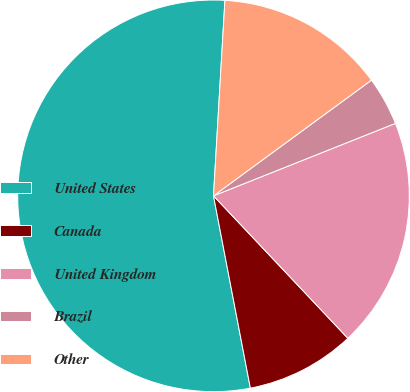<chart> <loc_0><loc_0><loc_500><loc_500><pie_chart><fcel>United States<fcel>Canada<fcel>United Kingdom<fcel>Brazil<fcel>Other<nl><fcel>53.95%<fcel>9.02%<fcel>19.0%<fcel>4.03%<fcel>14.01%<nl></chart> 